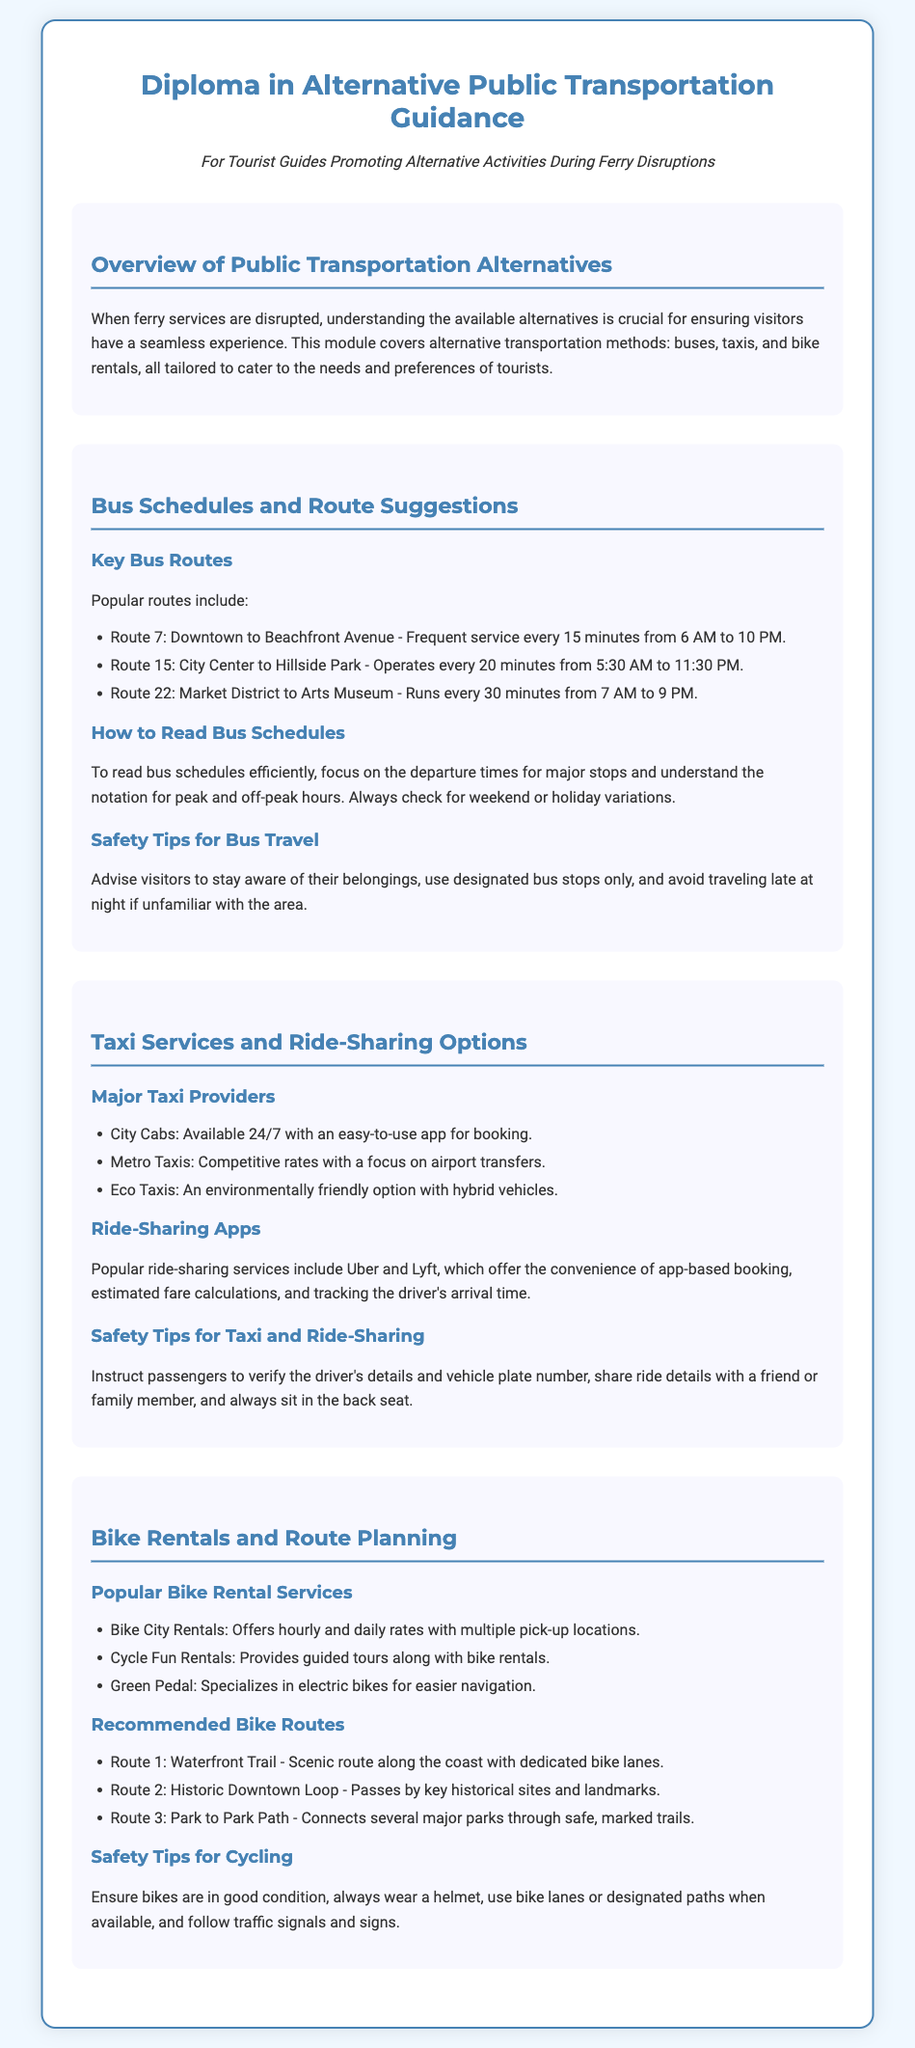What are the popular bus routes mentioned? The document lists specific bus routes as alternatives for travelers during ferry disruptions, including Route 7, Route 15, and Route 22.
Answer: Route 7, Route 15, Route 22 How often does Route 15 operate? The document specifies the frequency of Route 15, providing important scheduling information for visitors.
Answer: Every 20 minutes What is a major taxi provider listed in the document? The document lists several major taxi providers, which are relevant for tourists needing taxi services.
Answer: City Cabs What type of bikes does Green Pedal specialize in? The document includes information about bike rental services and their specializations, important for tourists considering biking.
Answer: Electric bikes What should passengers verify before getting into a taxi? The document outlines safety tips for taxi and ride-sharing, highlighting safety precautions for visitors.
Answer: Driver's details and vehicle plate number How long does Route 7 run from? The hours of service for Route 7 are detailed in the bus schedule section, critical for planning purposes.
Answer: 6 AM to 10 PM Which bike rental service provides guided tours? The document mentions popular bike rental services and their features, aiding tourists in selecting services.
Answer: Cycle Fun Rentals What is the total number of bus routes mentioned in the document? The document lists three specific bus routes, providing an overview of public transportation options.
Answer: Three What is advised to wear while cycling? The document emphasizes safety tips for cyclists, which is crucial for visitor safety during biking activities.
Answer: A helmet 